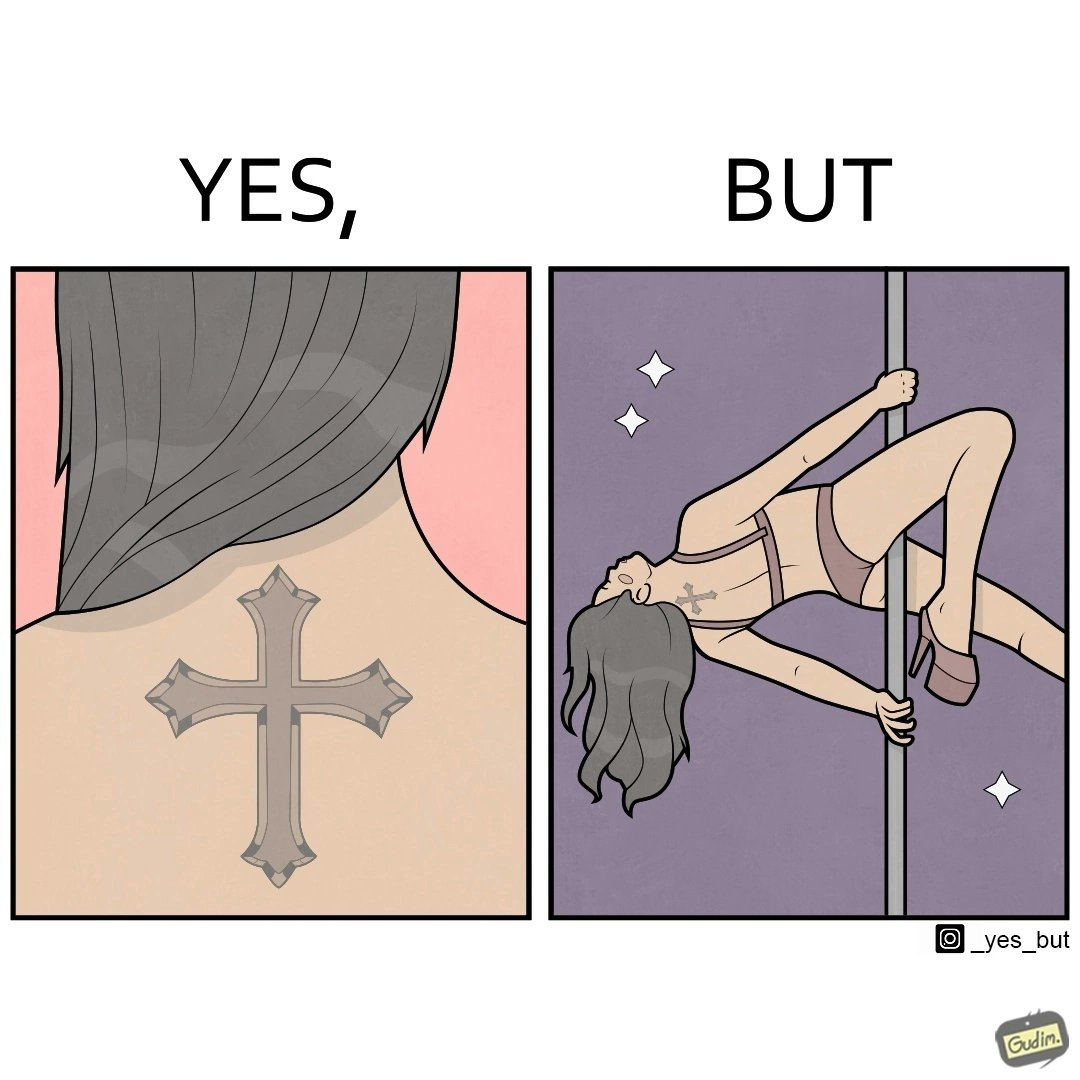Describe the contrast between the left and right parts of this image. In the left part of the image: a tatto of holy cross symbol on the back of a girl,maybe she follows christianity as her religion In the right part of the image: a pole dancer performing, having a tatto of holy cross symbol on her back 